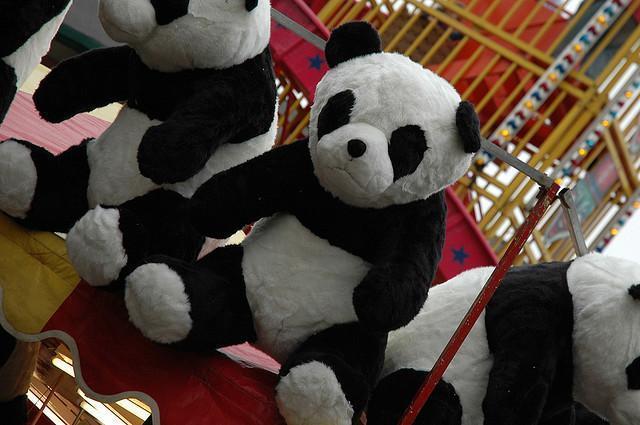How many teddy bears are there?
Give a very brief answer. 4. 